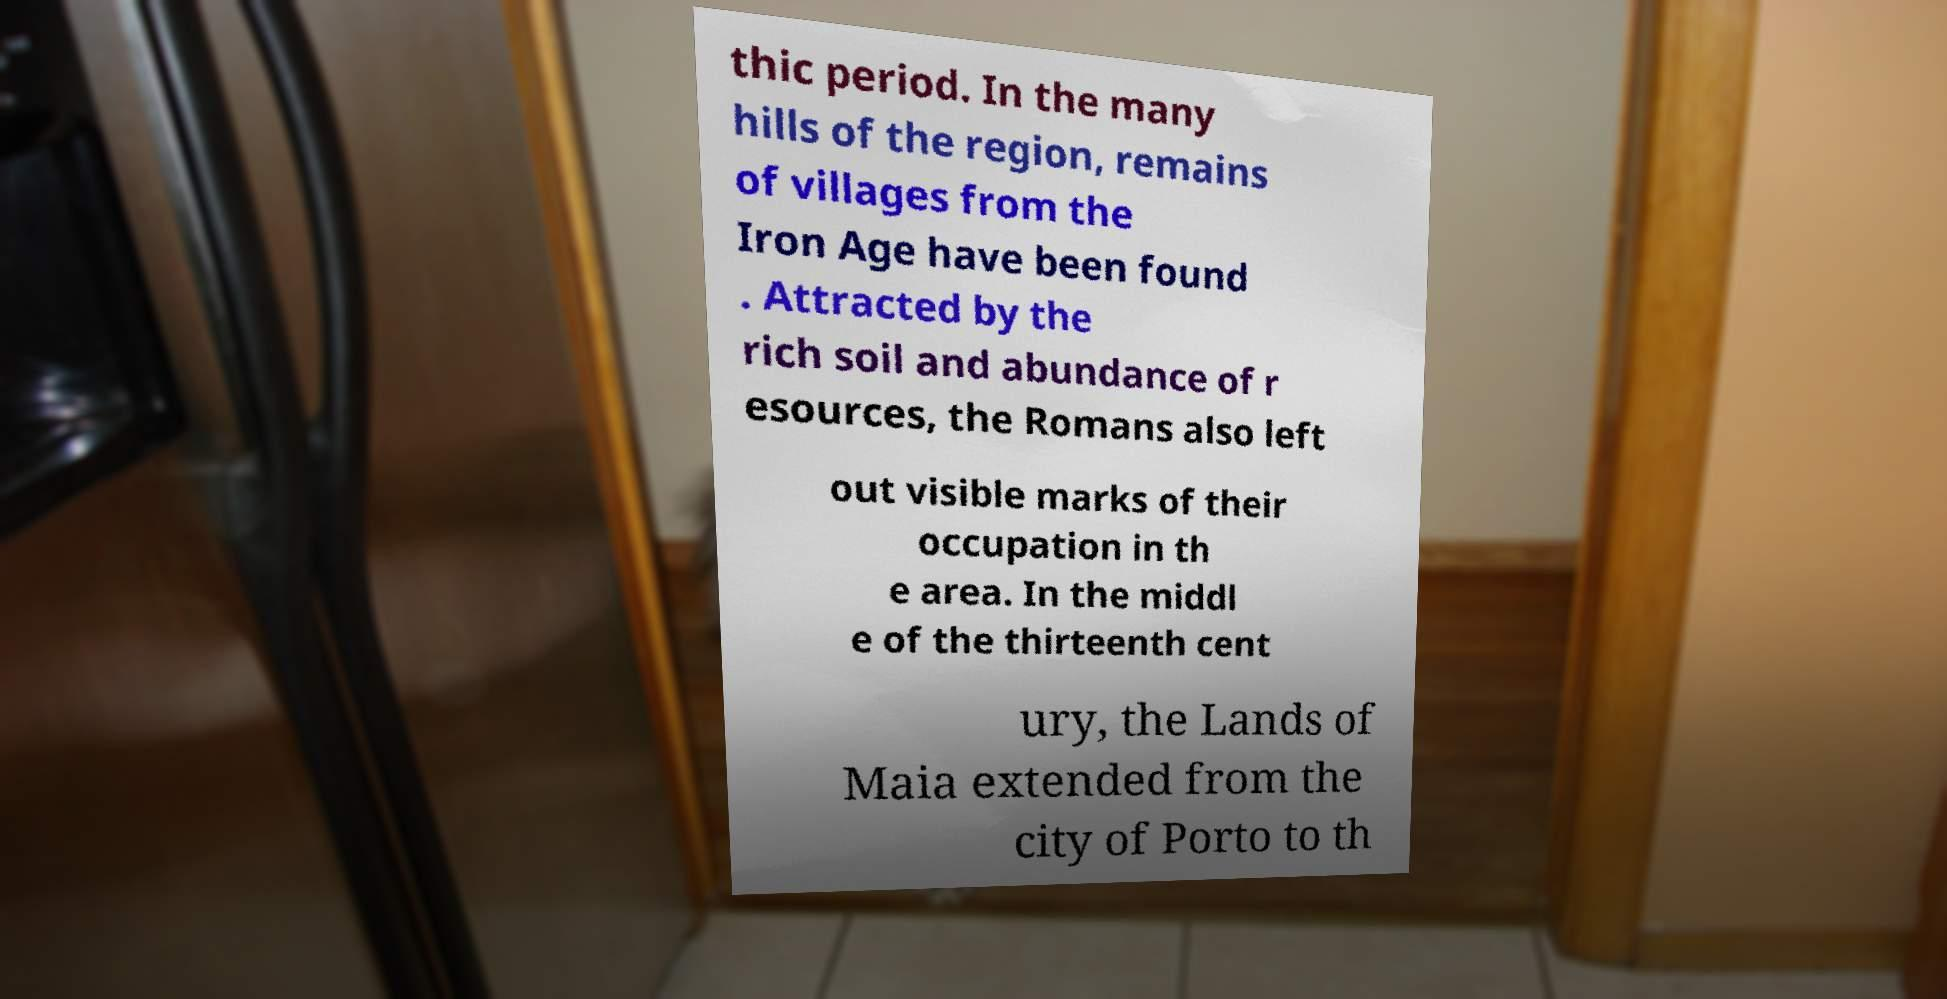Please identify and transcribe the text found in this image. thic period. In the many hills of the region, remains of villages from the Iron Age have been found . Attracted by the rich soil and abundance of r esources, the Romans also left out visible marks of their occupation in th e area. In the middl e of the thirteenth cent ury, the Lands of Maia extended from the city of Porto to th 